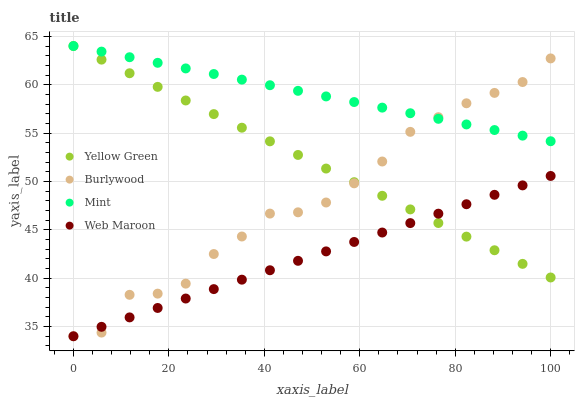Does Web Maroon have the minimum area under the curve?
Answer yes or no. Yes. Does Mint have the maximum area under the curve?
Answer yes or no. Yes. Does Mint have the minimum area under the curve?
Answer yes or no. No. Does Web Maroon have the maximum area under the curve?
Answer yes or no. No. Is Mint the smoothest?
Answer yes or no. Yes. Is Burlywood the roughest?
Answer yes or no. Yes. Is Web Maroon the smoothest?
Answer yes or no. No. Is Web Maroon the roughest?
Answer yes or no. No. Does Burlywood have the lowest value?
Answer yes or no. Yes. Does Mint have the lowest value?
Answer yes or no. No. Does Yellow Green have the highest value?
Answer yes or no. Yes. Does Web Maroon have the highest value?
Answer yes or no. No. Is Web Maroon less than Mint?
Answer yes or no. Yes. Is Mint greater than Web Maroon?
Answer yes or no. Yes. Does Web Maroon intersect Yellow Green?
Answer yes or no. Yes. Is Web Maroon less than Yellow Green?
Answer yes or no. No. Is Web Maroon greater than Yellow Green?
Answer yes or no. No. Does Web Maroon intersect Mint?
Answer yes or no. No. 